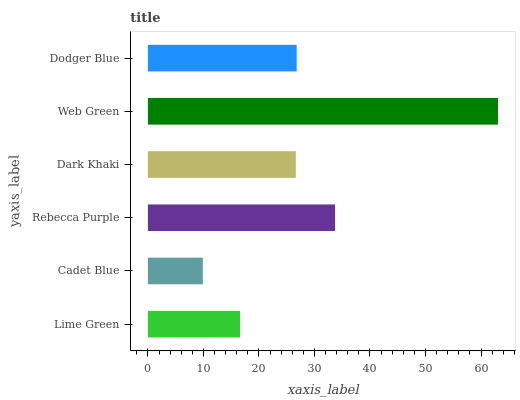Is Cadet Blue the minimum?
Answer yes or no. Yes. Is Web Green the maximum?
Answer yes or no. Yes. Is Rebecca Purple the minimum?
Answer yes or no. No. Is Rebecca Purple the maximum?
Answer yes or no. No. Is Rebecca Purple greater than Cadet Blue?
Answer yes or no. Yes. Is Cadet Blue less than Rebecca Purple?
Answer yes or no. Yes. Is Cadet Blue greater than Rebecca Purple?
Answer yes or no. No. Is Rebecca Purple less than Cadet Blue?
Answer yes or no. No. Is Dodger Blue the high median?
Answer yes or no. Yes. Is Dark Khaki the low median?
Answer yes or no. Yes. Is Dark Khaki the high median?
Answer yes or no. No. Is Lime Green the low median?
Answer yes or no. No. 